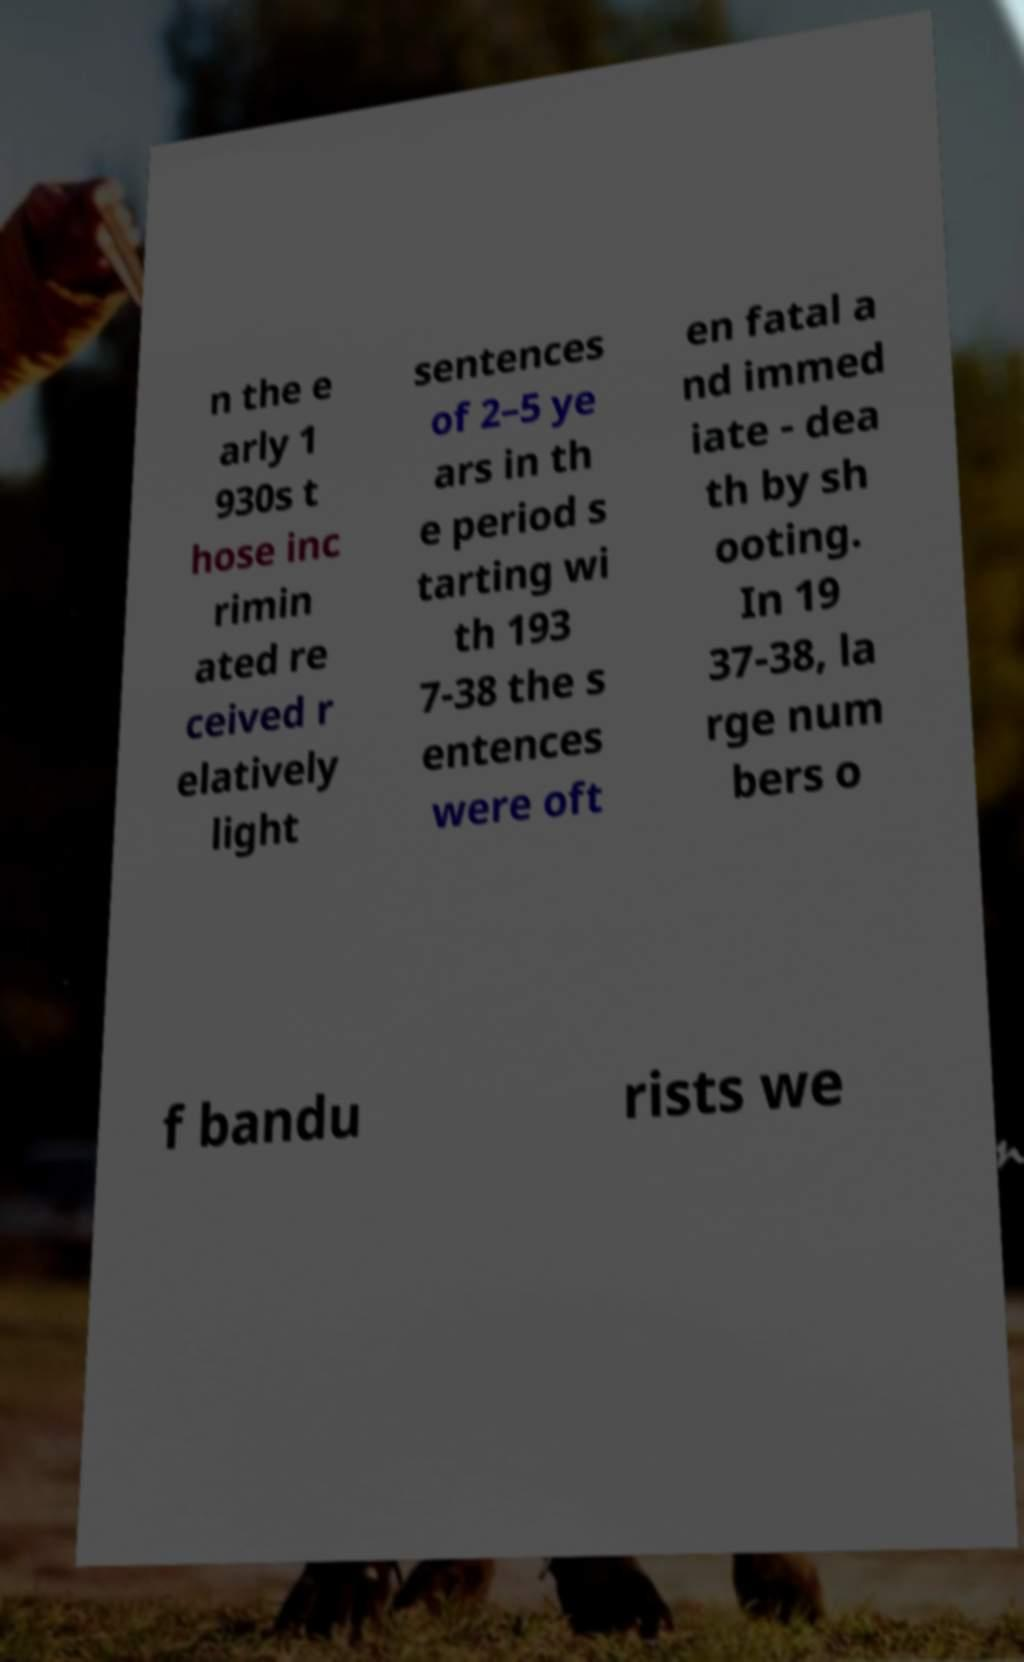I need the written content from this picture converted into text. Can you do that? n the e arly 1 930s t hose inc rimin ated re ceived r elatively light sentences of 2–5 ye ars in th e period s tarting wi th 193 7-38 the s entences were oft en fatal a nd immed iate - dea th by sh ooting. In 19 37-38, la rge num bers o f bandu rists we 